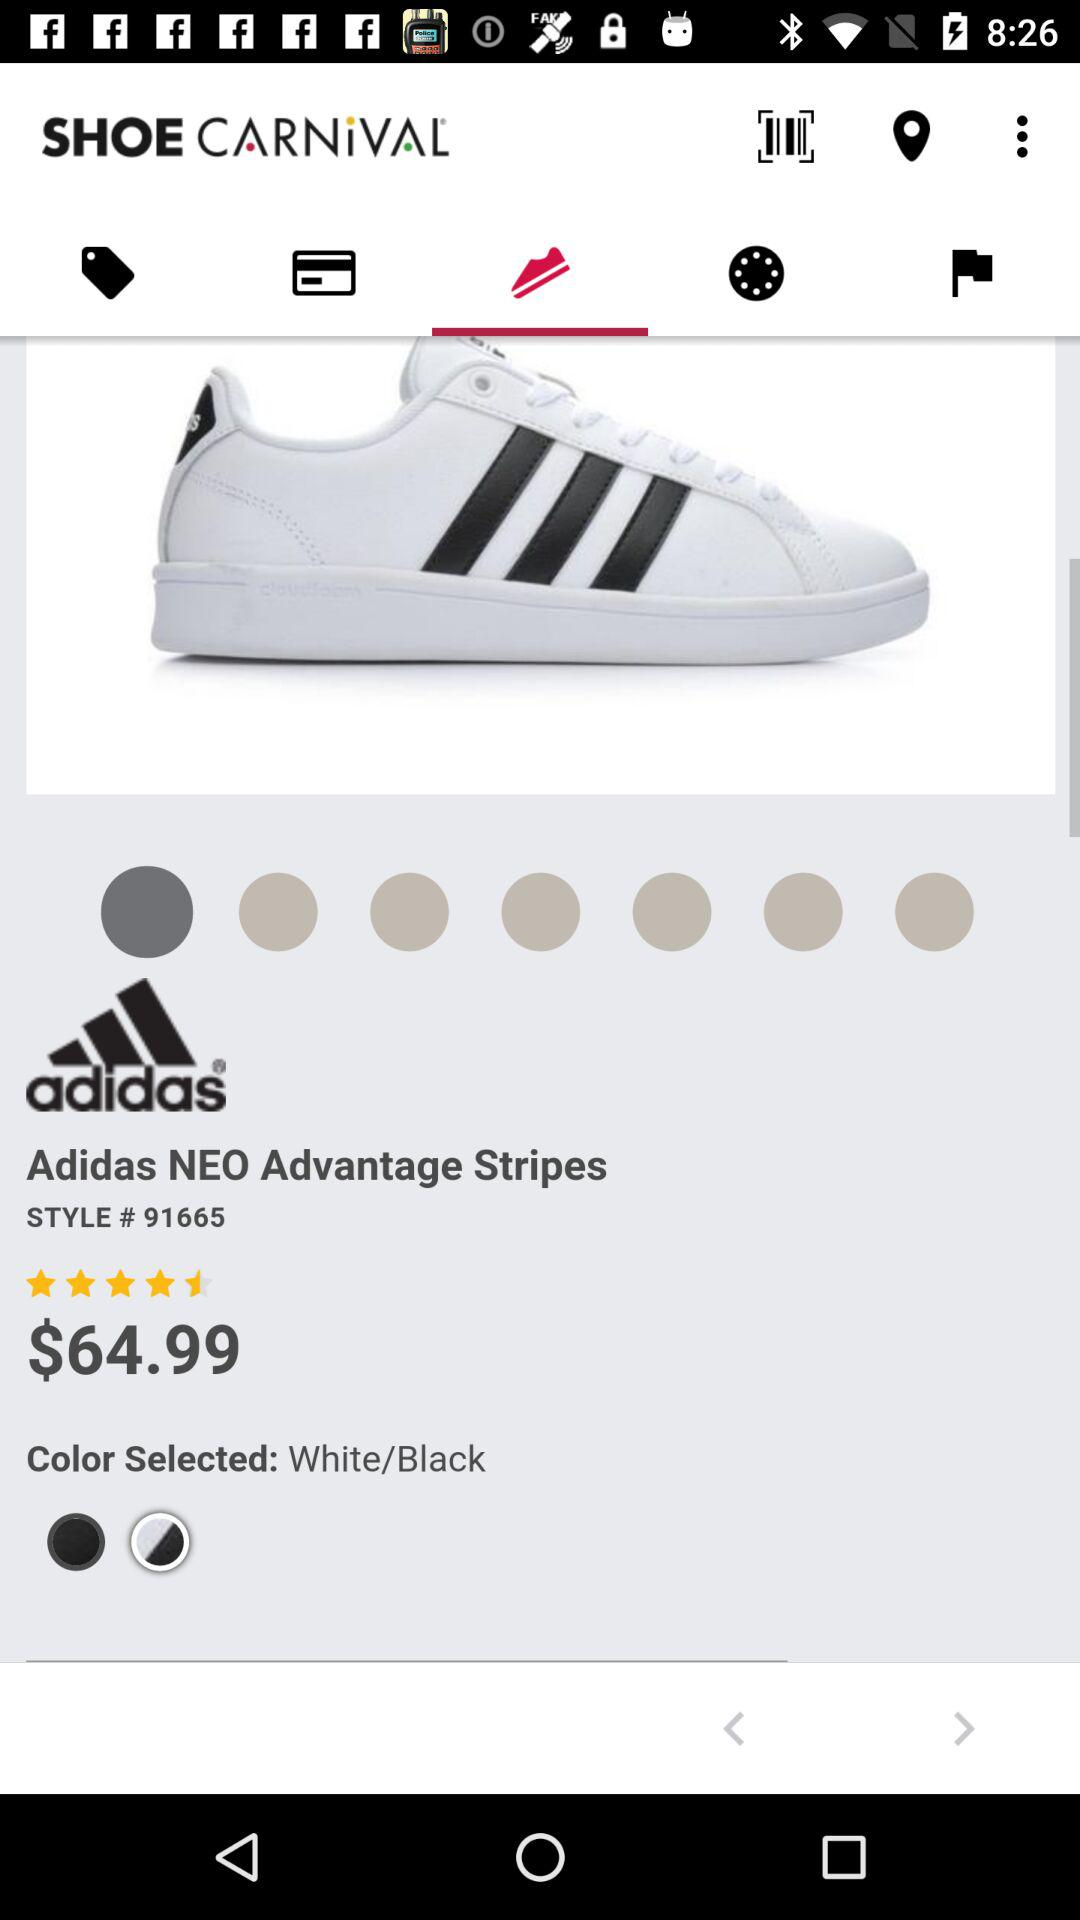How many colors are available for the product?
Answer the question using a single word or phrase. 2 